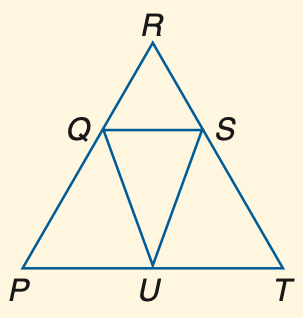Question: If P Q \cong U Q, P R \cong R T and m \angle P Q U = 40, find m \angle R.
Choices:
A. 40
B. 50
C. 60
D. 70
Answer with the letter. Answer: A Question: If R Q \cong R S and m \angle R Q S = 75, find m \angle R.
Choices:
A. 30
B. 40
C. 52.5
D. 75
Answer with the letter. Answer: A Question: If P Q \cong U Q and m \angle P = 32, find m \angle P U Q.
Choices:
A. 32
B. 74
C. 79
D. 116
Answer with the letter. Answer: A 